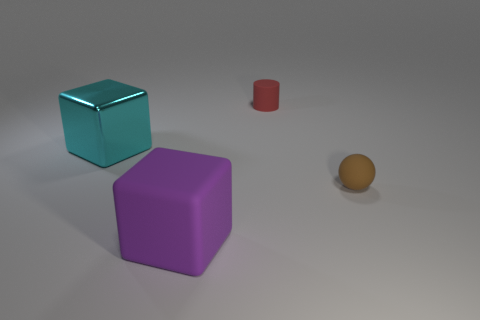What is the material of the cyan block?
Keep it short and to the point. Metal. How many other objects are there of the same shape as the purple object?
Keep it short and to the point. 1. What is the size of the red object?
Ensure brevity in your answer.  Small. How big is the thing that is both on the left side of the small red matte cylinder and on the right side of the metallic thing?
Your answer should be compact. Large. What is the shape of the small object left of the tiny brown matte object?
Offer a terse response. Cylinder. Is the material of the tiny brown object the same as the small cylinder behind the big matte thing?
Give a very brief answer. Yes. Do the brown object and the large matte object have the same shape?
Provide a succinct answer. No. There is a big cyan object that is the same shape as the big purple object; what is it made of?
Your answer should be compact. Metal. The object that is both in front of the red matte object and on the right side of the purple object is what color?
Your answer should be very brief. Brown. What color is the large metal object?
Offer a terse response. Cyan. 